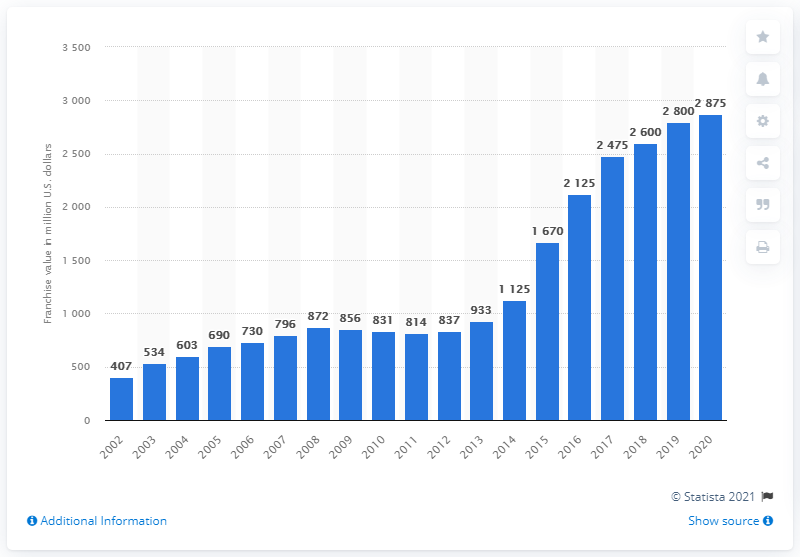List a handful of essential elements in this visual. The value of the Atlanta Falcons in dollars in 2020 was estimated to be $287.5 million. 